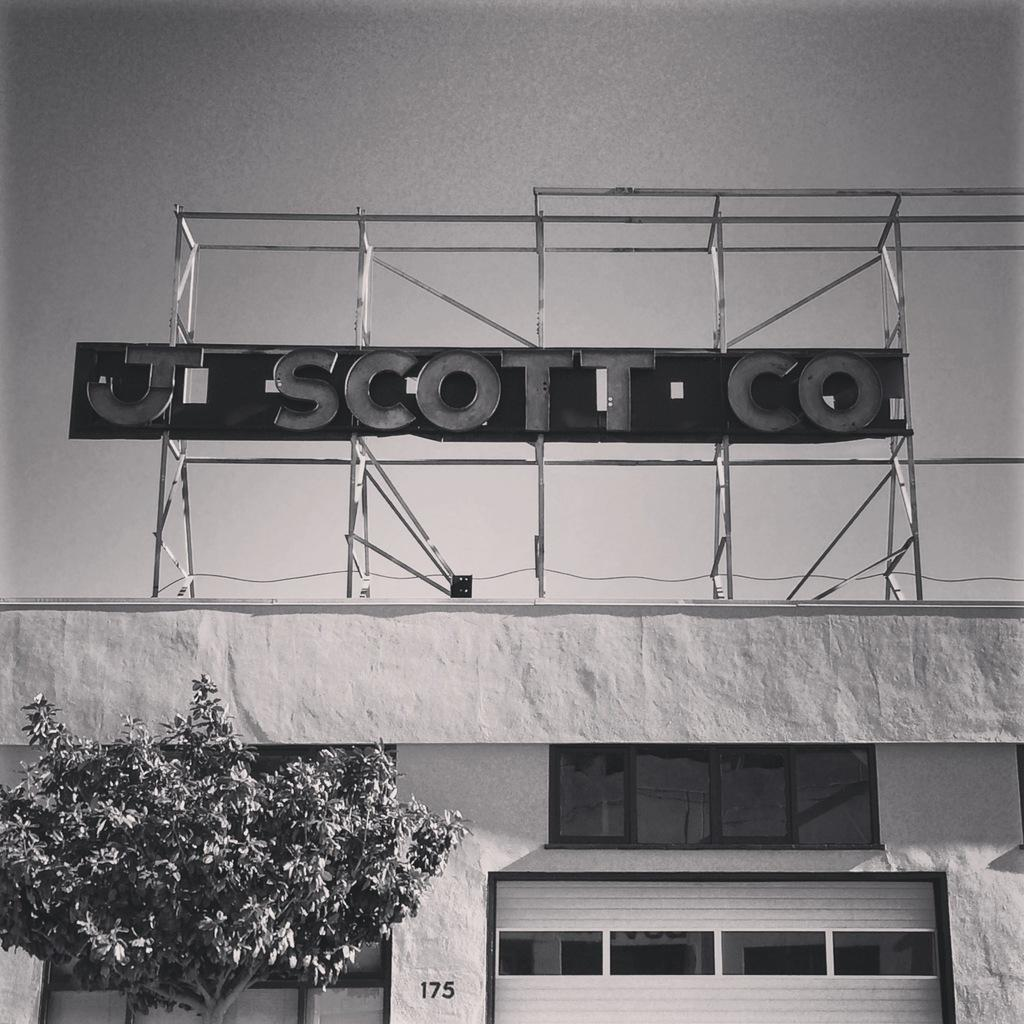<image>
Relay a brief, clear account of the picture shown. A sign above a white building that says "J Scott Co". 